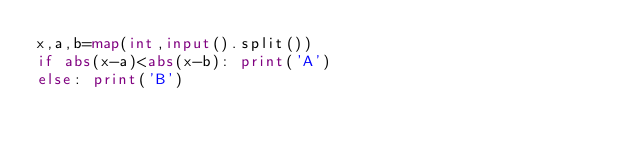<code> <loc_0><loc_0><loc_500><loc_500><_Python_>x,a,b=map(int,input().split())
if abs(x-a)<abs(x-b): print('A')
else: print('B')</code> 